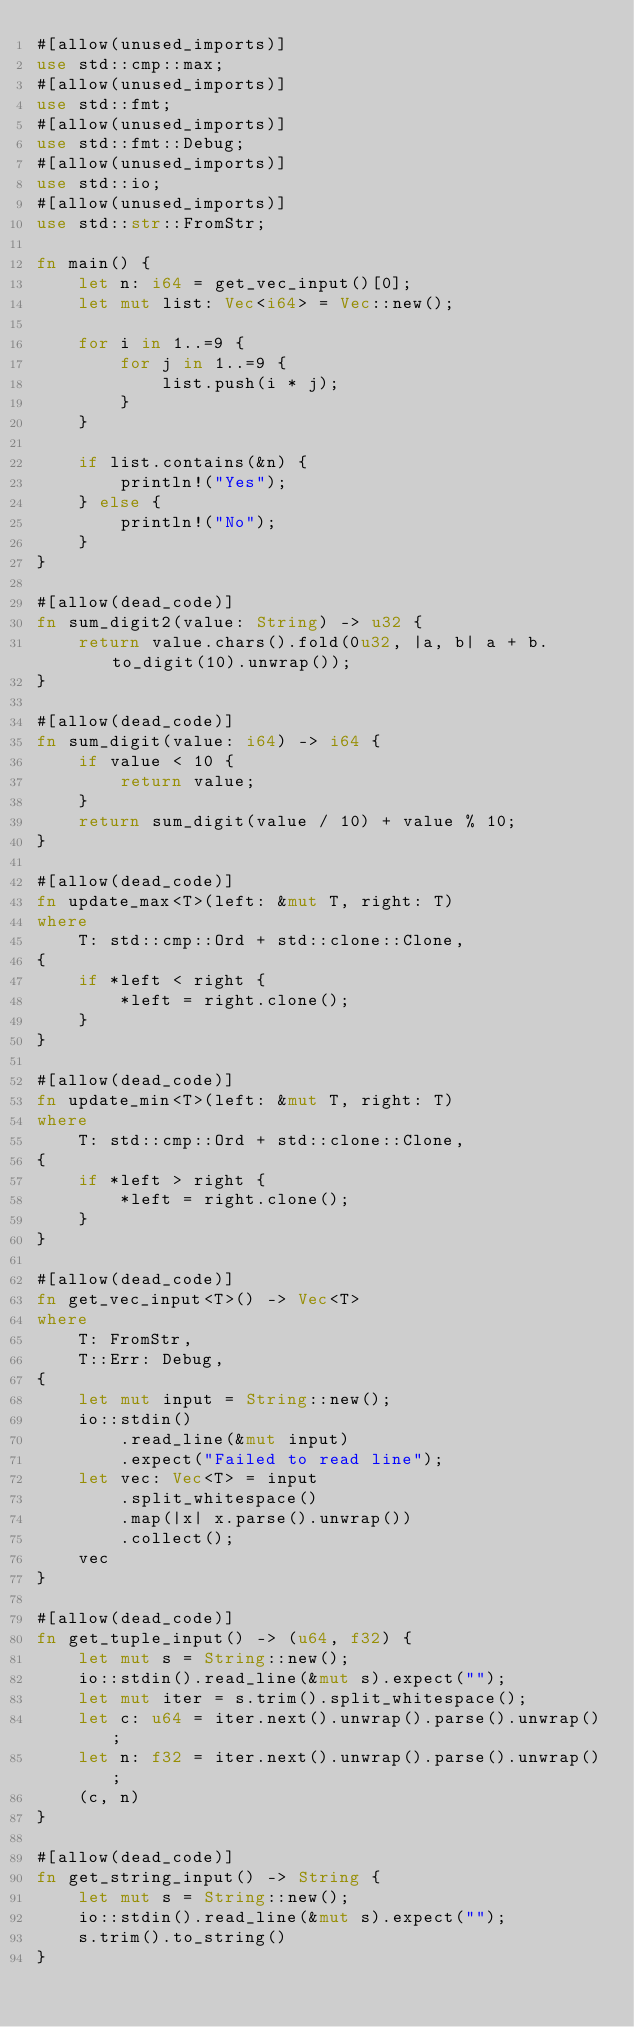<code> <loc_0><loc_0><loc_500><loc_500><_Rust_>#[allow(unused_imports)]
use std::cmp::max;
#[allow(unused_imports)]
use std::fmt;
#[allow(unused_imports)]
use std::fmt::Debug;
#[allow(unused_imports)]
use std::io;
#[allow(unused_imports)]
use std::str::FromStr;

fn main() {
    let n: i64 = get_vec_input()[0];
    let mut list: Vec<i64> = Vec::new();

    for i in 1..=9 {
        for j in 1..=9 {
            list.push(i * j);
        }
    }

    if list.contains(&n) {
        println!("Yes");
    } else {
        println!("No");
    }
}

#[allow(dead_code)]
fn sum_digit2(value: String) -> u32 {
    return value.chars().fold(0u32, |a, b| a + b.to_digit(10).unwrap());
}

#[allow(dead_code)]
fn sum_digit(value: i64) -> i64 {
    if value < 10 {
        return value;
    }
    return sum_digit(value / 10) + value % 10;
}

#[allow(dead_code)]
fn update_max<T>(left: &mut T, right: T)
where
    T: std::cmp::Ord + std::clone::Clone,
{
    if *left < right {
        *left = right.clone();
    }
}

#[allow(dead_code)]
fn update_min<T>(left: &mut T, right: T)
where
    T: std::cmp::Ord + std::clone::Clone,
{
    if *left > right {
        *left = right.clone();
    }
}

#[allow(dead_code)]
fn get_vec_input<T>() -> Vec<T>
where
    T: FromStr,
    T::Err: Debug,
{
    let mut input = String::new();
    io::stdin()
        .read_line(&mut input)
        .expect("Failed to read line");
    let vec: Vec<T> = input
        .split_whitespace()
        .map(|x| x.parse().unwrap())
        .collect();
    vec
}

#[allow(dead_code)]
fn get_tuple_input() -> (u64, f32) {
    let mut s = String::new();
    io::stdin().read_line(&mut s).expect("");
    let mut iter = s.trim().split_whitespace();
    let c: u64 = iter.next().unwrap().parse().unwrap();
    let n: f32 = iter.next().unwrap().parse().unwrap();
    (c, n)
}

#[allow(dead_code)]
fn get_string_input() -> String {
    let mut s = String::new();
    io::stdin().read_line(&mut s).expect("");
    s.trim().to_string()
}
</code> 